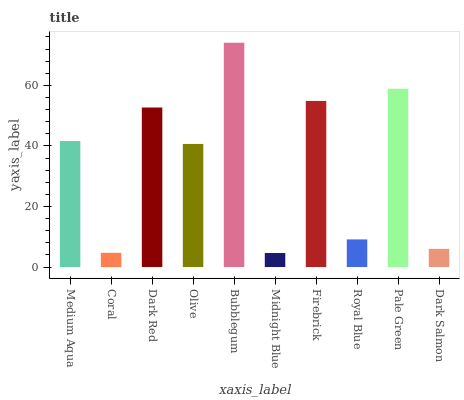Is Midnight Blue the minimum?
Answer yes or no. Yes. Is Bubblegum the maximum?
Answer yes or no. Yes. Is Coral the minimum?
Answer yes or no. No. Is Coral the maximum?
Answer yes or no. No. Is Medium Aqua greater than Coral?
Answer yes or no. Yes. Is Coral less than Medium Aqua?
Answer yes or no. Yes. Is Coral greater than Medium Aqua?
Answer yes or no. No. Is Medium Aqua less than Coral?
Answer yes or no. No. Is Medium Aqua the high median?
Answer yes or no. Yes. Is Olive the low median?
Answer yes or no. Yes. Is Midnight Blue the high median?
Answer yes or no. No. Is Dark Red the low median?
Answer yes or no. No. 